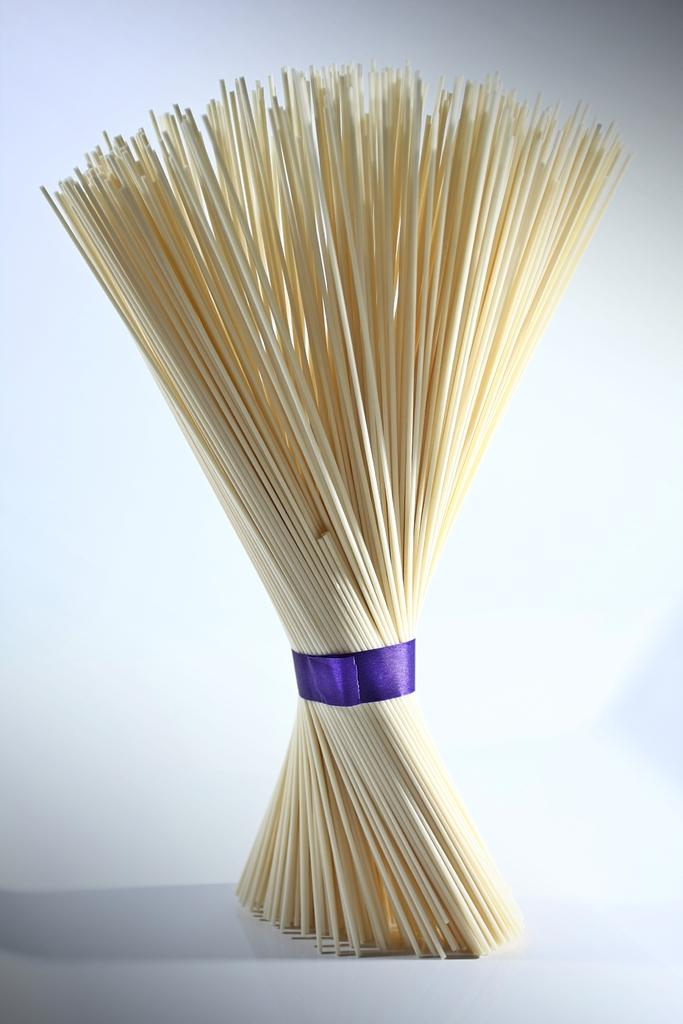What object is the main subject of the image? There is a broomstick in the image. How is the broomstick decorated or adorned? The broomstick is tied with a blue ribbon. Where is the broomstick placed in the image? The broomstick is placed on a white table. What color is the background of the image? The background of the image is white. What time of day is depicted in the image, and are there any planes visible? The time of day is not mentioned in the image, and there are no planes visible. Is there a crown placed on the broomstick in the image? No, there is no crown present in the image. 